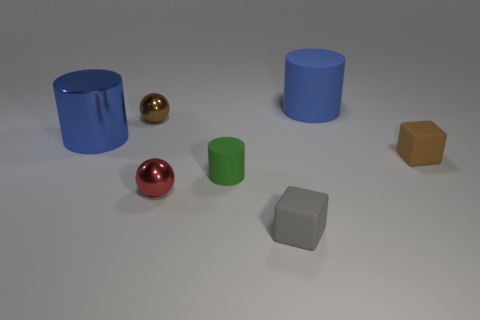There is a brown object that is the same shape as the tiny gray object; what is it made of?
Make the answer very short. Rubber. Is the number of small red balls right of the red object greater than the number of green rubber things?
Ensure brevity in your answer.  No. Are there any other things of the same color as the big metal object?
Ensure brevity in your answer.  Yes. The small gray thing that is made of the same material as the tiny green cylinder is what shape?
Offer a terse response. Cube. Is the big blue cylinder left of the gray rubber thing made of the same material as the red ball?
Your answer should be very brief. Yes. What shape is the large metallic thing that is the same color as the large matte thing?
Provide a short and direct response. Cylinder. There is a big object in front of the brown ball; is its color the same as the small shiny ball that is in front of the tiny cylinder?
Offer a very short reply. No. What number of tiny things are on the right side of the small gray rubber block and behind the tiny brown block?
Offer a very short reply. 0. What is the material of the small brown ball?
Your response must be concise. Metal. There is a metal object that is the same size as the red metal sphere; what is its shape?
Make the answer very short. Sphere. 